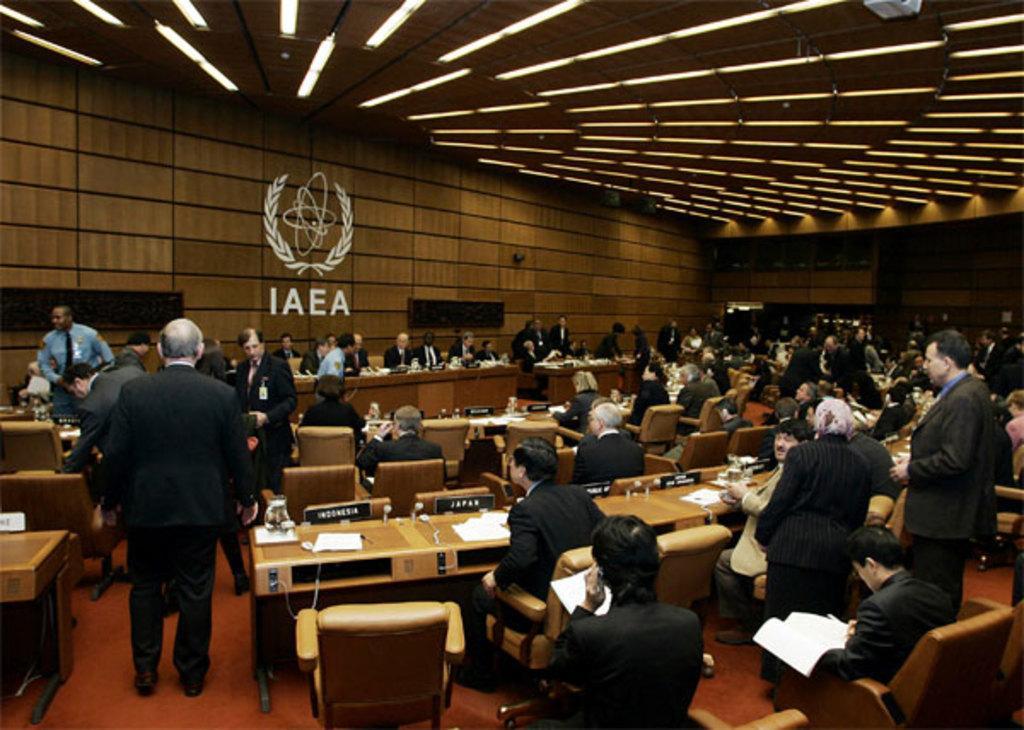Can you describe this image briefly? In this Image I see number of people, in which most of them are sitting on chairs and few of them are standing, I can also see that most of them are wearing suits and there are tables in front of them on which there are papers and other things. In the background I see the wall and I see a logo, a word and lights on the ceiling. 